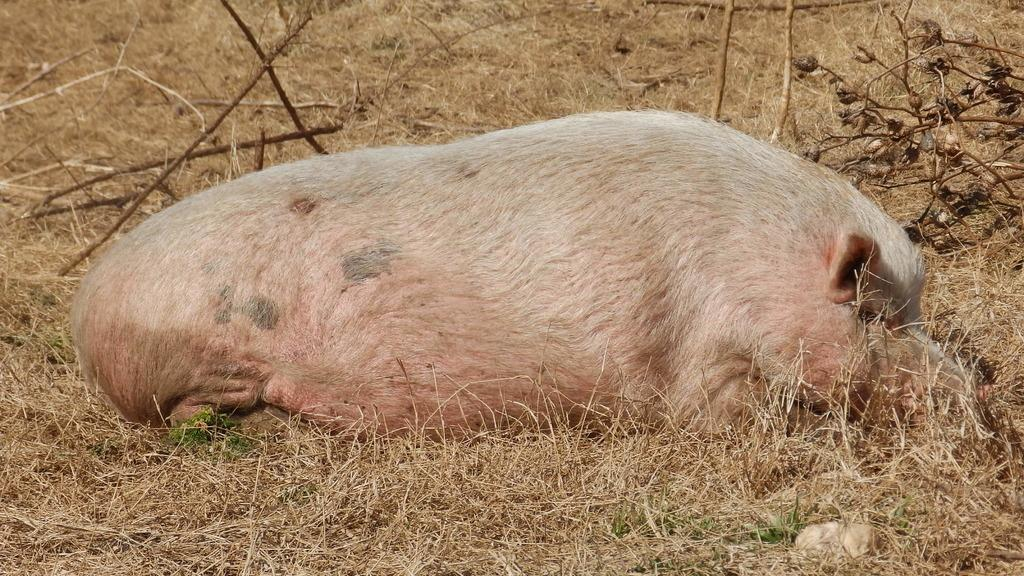What type of animal can be seen in the image? There is an animal in the image, but its specific type cannot be determined from the provided facts. Can you describe the color of the animal in the image? The animal is light-pink and white in color. What type of vegetation is visible in the image? Dry grass is visible in the image. What else can be seen in the image besides the animal and vegetation? There are sticks in the image. What is the animal's opinion on the notebook in the image? There is no notebook present in the image, so it is not possible to determine the animal's opinion on it. 